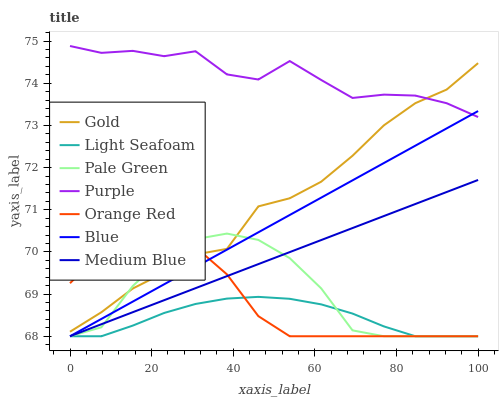Does Light Seafoam have the minimum area under the curve?
Answer yes or no. Yes. Does Purple have the maximum area under the curve?
Answer yes or no. Yes. Does Gold have the minimum area under the curve?
Answer yes or no. No. Does Gold have the maximum area under the curve?
Answer yes or no. No. Is Medium Blue the smoothest?
Answer yes or no. Yes. Is Purple the roughest?
Answer yes or no. Yes. Is Gold the smoothest?
Answer yes or no. No. Is Gold the roughest?
Answer yes or no. No. Does Blue have the lowest value?
Answer yes or no. Yes. Does Gold have the lowest value?
Answer yes or no. No. Does Purple have the highest value?
Answer yes or no. Yes. Does Gold have the highest value?
Answer yes or no. No. Is Pale Green less than Purple?
Answer yes or no. Yes. Is Purple greater than Medium Blue?
Answer yes or no. Yes. Does Medium Blue intersect Light Seafoam?
Answer yes or no. Yes. Is Medium Blue less than Light Seafoam?
Answer yes or no. No. Is Medium Blue greater than Light Seafoam?
Answer yes or no. No. Does Pale Green intersect Purple?
Answer yes or no. No. 